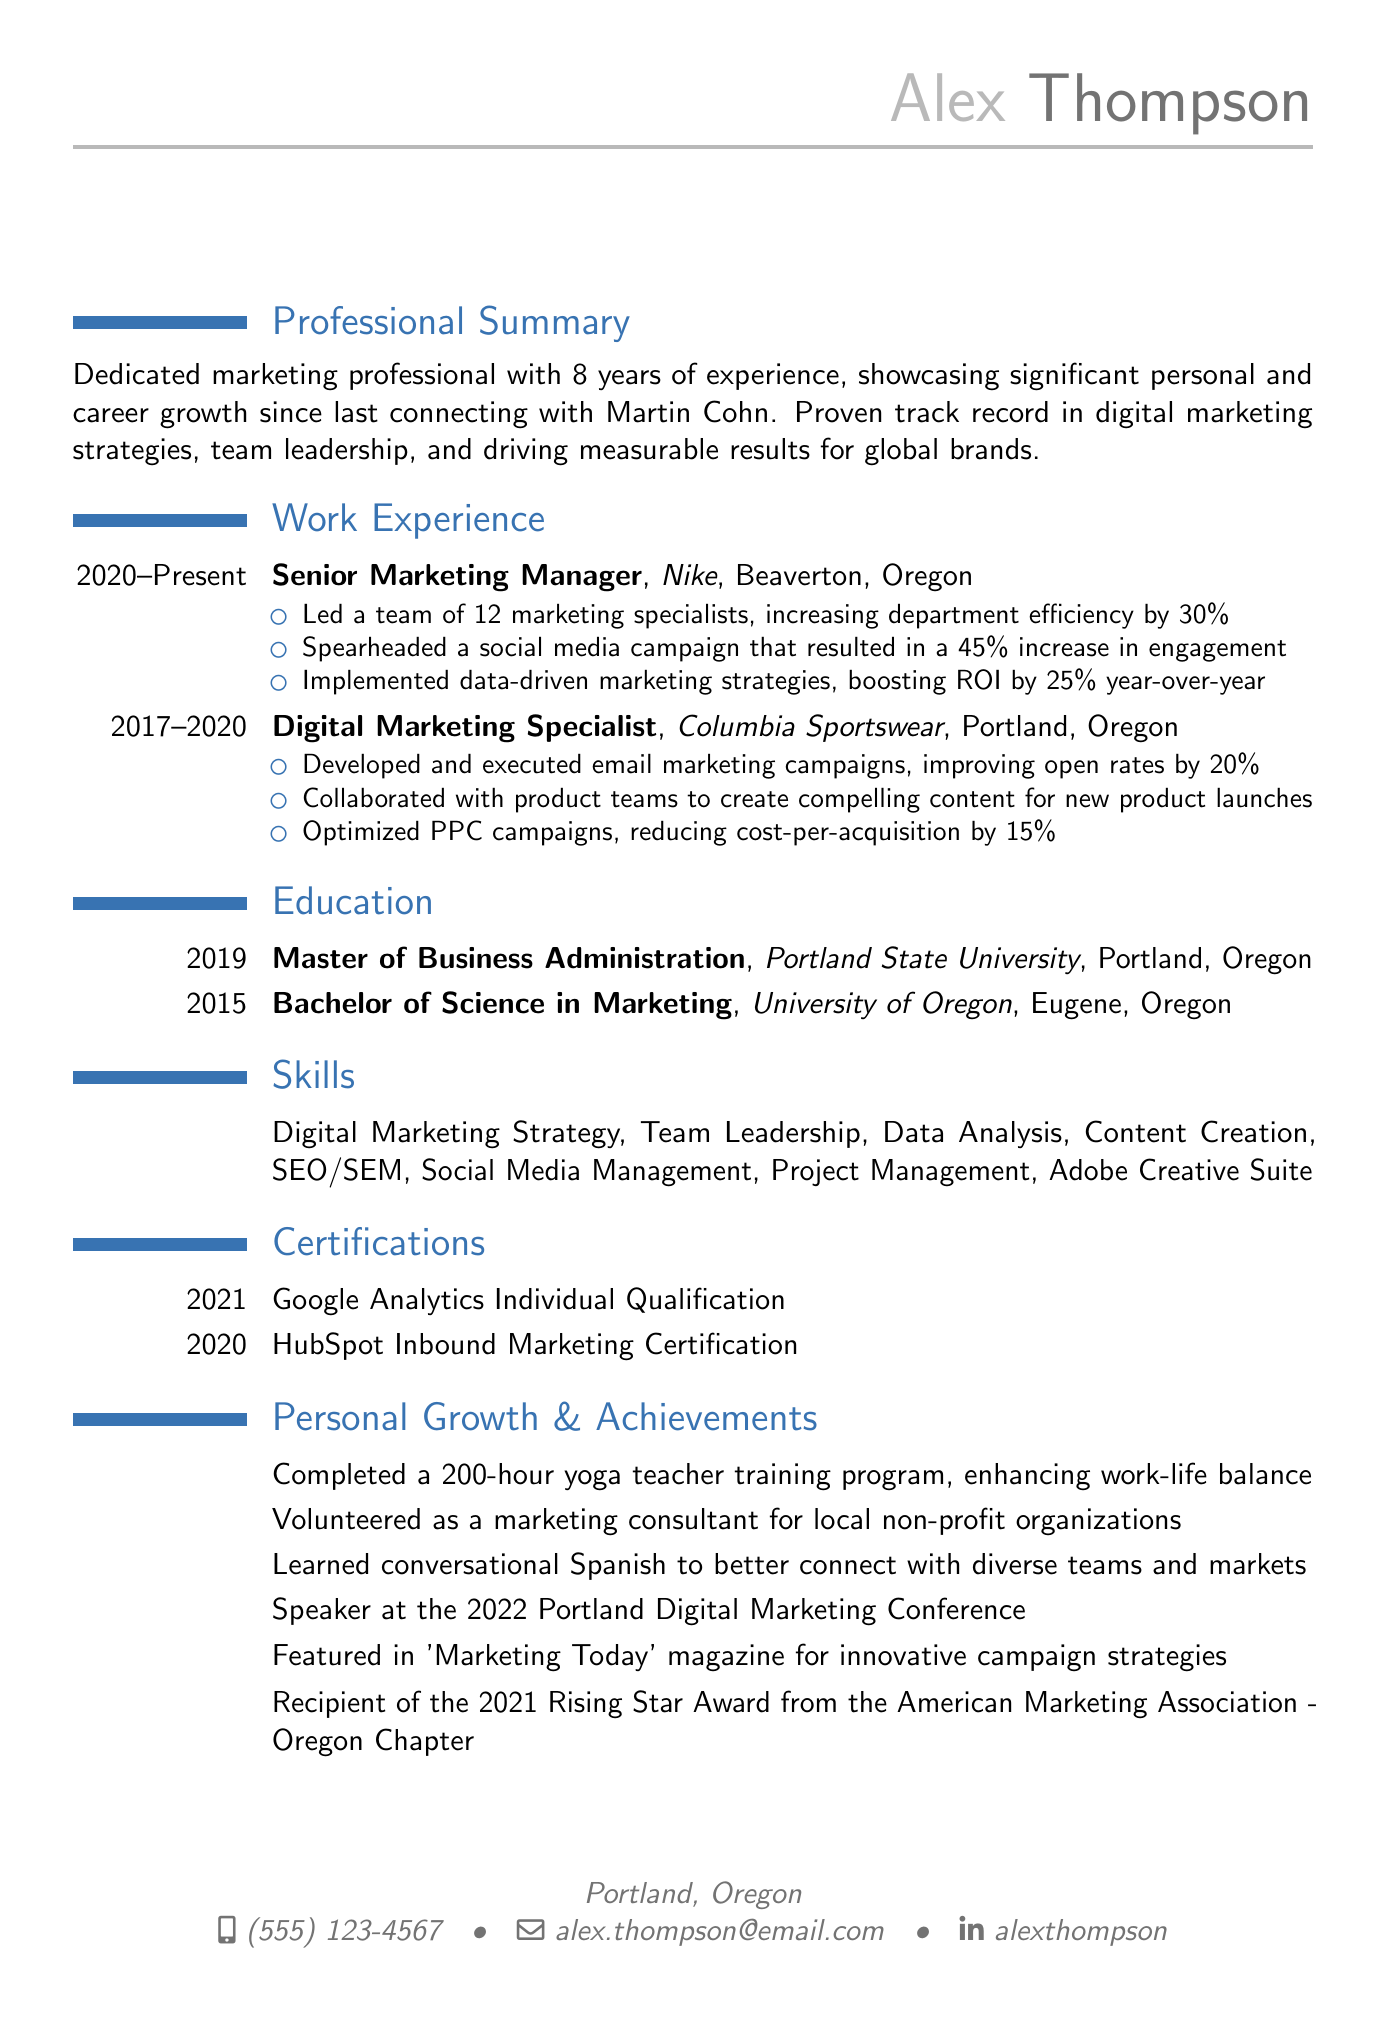What is Alex Thompson's current job title? The job title is listed under the work experience section for the current position held.
Answer: Senior Marketing Manager In what year did Alex graduate with a Master of Business Administration? The graduation year is stated in the education section for the MBA degree.
Answer: 2019 How many years of experience does Alex have in marketing? The years of experience are summarized in the professional summary section of the resume.
Answer: 8 years Which company did Alex work for as a Digital Marketing Specialist? The company name is mentioned in the work experience section for that position.
Answer: Columbia Sportswear What percentage increase in engagement resulted from the social media campaign led by Alex? This information is provided in the achievements under the current position in the work experience section.
Answer: 45% Which certification was obtained by Alex in 2021? The year of the certification is stated in the certifications section of the document.
Answer: Google Analytics Individual Qualification How many marketing specialists did Alex lead at Nike? The number of team members Alex managed is specified in the achievements for the current position.
Answer: 12 What personal growth activity did Alex complete to enhance work-life balance? This activity is listed under the personal growth achievements section of the resume.
Answer: 200-hour yoga teacher training program What award did Alex receive from the American Marketing Association? The specific award is noted in the professional achievements section of the resume.
Answer: Rising Star Award 